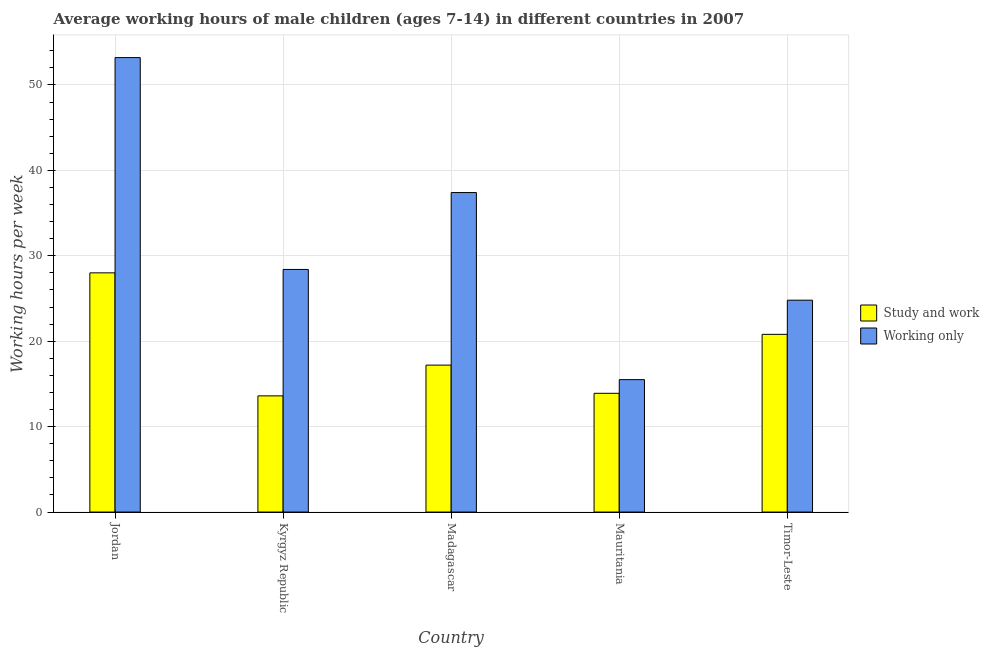How many different coloured bars are there?
Provide a succinct answer. 2. How many groups of bars are there?
Keep it short and to the point. 5. How many bars are there on the 5th tick from the right?
Your response must be concise. 2. What is the label of the 1st group of bars from the left?
Offer a very short reply. Jordan. Across all countries, what is the maximum average working hour of children involved in only work?
Your answer should be very brief. 53.2. Across all countries, what is the minimum average working hour of children involved in only work?
Keep it short and to the point. 15.5. In which country was the average working hour of children involved in only work maximum?
Your answer should be compact. Jordan. In which country was the average working hour of children involved in study and work minimum?
Ensure brevity in your answer.  Kyrgyz Republic. What is the total average working hour of children involved in study and work in the graph?
Your answer should be very brief. 93.5. What is the difference between the average working hour of children involved in only work in Madagascar and that in Mauritania?
Provide a short and direct response. 21.9. What is the difference between the average working hour of children involved in only work in Madagascar and the average working hour of children involved in study and work in Jordan?
Provide a short and direct response. 9.4. What is the average average working hour of children involved in only work per country?
Your answer should be very brief. 31.86. What is the difference between the average working hour of children involved in only work and average working hour of children involved in study and work in Madagascar?
Offer a terse response. 20.2. What is the ratio of the average working hour of children involved in study and work in Jordan to that in Timor-Leste?
Provide a short and direct response. 1.35. What is the difference between the highest and the second highest average working hour of children involved in study and work?
Offer a terse response. 7.2. What is the difference between the highest and the lowest average working hour of children involved in only work?
Your response must be concise. 37.7. Is the sum of the average working hour of children involved in only work in Kyrgyz Republic and Mauritania greater than the maximum average working hour of children involved in study and work across all countries?
Ensure brevity in your answer.  Yes. What does the 1st bar from the left in Madagascar represents?
Offer a very short reply. Study and work. What does the 2nd bar from the right in Kyrgyz Republic represents?
Offer a terse response. Study and work. How many bars are there?
Make the answer very short. 10. Are all the bars in the graph horizontal?
Your answer should be very brief. No. How many countries are there in the graph?
Provide a short and direct response. 5. What is the difference between two consecutive major ticks on the Y-axis?
Your answer should be very brief. 10. Does the graph contain any zero values?
Offer a very short reply. No. Where does the legend appear in the graph?
Give a very brief answer. Center right. How many legend labels are there?
Your answer should be compact. 2. What is the title of the graph?
Your response must be concise. Average working hours of male children (ages 7-14) in different countries in 2007. What is the label or title of the Y-axis?
Give a very brief answer. Working hours per week. What is the Working hours per week of Working only in Jordan?
Offer a very short reply. 53.2. What is the Working hours per week of Working only in Kyrgyz Republic?
Make the answer very short. 28.4. What is the Working hours per week in Working only in Madagascar?
Your answer should be compact. 37.4. What is the Working hours per week of Working only in Mauritania?
Provide a short and direct response. 15.5. What is the Working hours per week in Study and work in Timor-Leste?
Your response must be concise. 20.8. What is the Working hours per week of Working only in Timor-Leste?
Keep it short and to the point. 24.8. Across all countries, what is the maximum Working hours per week in Study and work?
Keep it short and to the point. 28. Across all countries, what is the maximum Working hours per week of Working only?
Give a very brief answer. 53.2. Across all countries, what is the minimum Working hours per week in Working only?
Give a very brief answer. 15.5. What is the total Working hours per week of Study and work in the graph?
Your answer should be very brief. 93.5. What is the total Working hours per week in Working only in the graph?
Provide a short and direct response. 159.3. What is the difference between the Working hours per week in Working only in Jordan and that in Kyrgyz Republic?
Ensure brevity in your answer.  24.8. What is the difference between the Working hours per week of Study and work in Jordan and that in Madagascar?
Provide a short and direct response. 10.8. What is the difference between the Working hours per week of Working only in Jordan and that in Madagascar?
Make the answer very short. 15.8. What is the difference between the Working hours per week in Study and work in Jordan and that in Mauritania?
Give a very brief answer. 14.1. What is the difference between the Working hours per week of Working only in Jordan and that in Mauritania?
Offer a terse response. 37.7. What is the difference between the Working hours per week in Working only in Jordan and that in Timor-Leste?
Your response must be concise. 28.4. What is the difference between the Working hours per week of Study and work in Kyrgyz Republic and that in Madagascar?
Provide a succinct answer. -3.6. What is the difference between the Working hours per week of Study and work in Kyrgyz Republic and that in Mauritania?
Your response must be concise. -0.3. What is the difference between the Working hours per week in Working only in Kyrgyz Republic and that in Mauritania?
Give a very brief answer. 12.9. What is the difference between the Working hours per week in Study and work in Kyrgyz Republic and that in Timor-Leste?
Provide a short and direct response. -7.2. What is the difference between the Working hours per week of Study and work in Madagascar and that in Mauritania?
Provide a short and direct response. 3.3. What is the difference between the Working hours per week of Working only in Madagascar and that in Mauritania?
Provide a succinct answer. 21.9. What is the difference between the Working hours per week in Working only in Madagascar and that in Timor-Leste?
Provide a succinct answer. 12.6. What is the difference between the Working hours per week of Study and work in Mauritania and that in Timor-Leste?
Offer a terse response. -6.9. What is the difference between the Working hours per week in Working only in Mauritania and that in Timor-Leste?
Offer a terse response. -9.3. What is the difference between the Working hours per week of Study and work in Jordan and the Working hours per week of Working only in Madagascar?
Your response must be concise. -9.4. What is the difference between the Working hours per week in Study and work in Jordan and the Working hours per week in Working only in Timor-Leste?
Provide a succinct answer. 3.2. What is the difference between the Working hours per week of Study and work in Kyrgyz Republic and the Working hours per week of Working only in Madagascar?
Offer a very short reply. -23.8. What is the difference between the Working hours per week in Study and work in Kyrgyz Republic and the Working hours per week in Working only in Timor-Leste?
Your answer should be compact. -11.2. What is the difference between the Working hours per week in Study and work in Madagascar and the Working hours per week in Working only in Mauritania?
Your answer should be very brief. 1.7. What is the difference between the Working hours per week in Study and work in Madagascar and the Working hours per week in Working only in Timor-Leste?
Make the answer very short. -7.6. What is the average Working hours per week in Study and work per country?
Ensure brevity in your answer.  18.7. What is the average Working hours per week of Working only per country?
Offer a terse response. 31.86. What is the difference between the Working hours per week in Study and work and Working hours per week in Working only in Jordan?
Offer a very short reply. -25.2. What is the difference between the Working hours per week of Study and work and Working hours per week of Working only in Kyrgyz Republic?
Provide a succinct answer. -14.8. What is the difference between the Working hours per week of Study and work and Working hours per week of Working only in Madagascar?
Offer a very short reply. -20.2. What is the difference between the Working hours per week of Study and work and Working hours per week of Working only in Mauritania?
Offer a very short reply. -1.6. What is the difference between the Working hours per week of Study and work and Working hours per week of Working only in Timor-Leste?
Give a very brief answer. -4. What is the ratio of the Working hours per week in Study and work in Jordan to that in Kyrgyz Republic?
Make the answer very short. 2.06. What is the ratio of the Working hours per week of Working only in Jordan to that in Kyrgyz Republic?
Keep it short and to the point. 1.87. What is the ratio of the Working hours per week of Study and work in Jordan to that in Madagascar?
Provide a succinct answer. 1.63. What is the ratio of the Working hours per week of Working only in Jordan to that in Madagascar?
Your response must be concise. 1.42. What is the ratio of the Working hours per week in Study and work in Jordan to that in Mauritania?
Your response must be concise. 2.01. What is the ratio of the Working hours per week of Working only in Jordan to that in Mauritania?
Your answer should be very brief. 3.43. What is the ratio of the Working hours per week in Study and work in Jordan to that in Timor-Leste?
Your response must be concise. 1.35. What is the ratio of the Working hours per week in Working only in Jordan to that in Timor-Leste?
Your answer should be compact. 2.15. What is the ratio of the Working hours per week of Study and work in Kyrgyz Republic to that in Madagascar?
Provide a short and direct response. 0.79. What is the ratio of the Working hours per week in Working only in Kyrgyz Republic to that in Madagascar?
Give a very brief answer. 0.76. What is the ratio of the Working hours per week of Study and work in Kyrgyz Republic to that in Mauritania?
Ensure brevity in your answer.  0.98. What is the ratio of the Working hours per week of Working only in Kyrgyz Republic to that in Mauritania?
Ensure brevity in your answer.  1.83. What is the ratio of the Working hours per week of Study and work in Kyrgyz Republic to that in Timor-Leste?
Ensure brevity in your answer.  0.65. What is the ratio of the Working hours per week in Working only in Kyrgyz Republic to that in Timor-Leste?
Give a very brief answer. 1.15. What is the ratio of the Working hours per week in Study and work in Madagascar to that in Mauritania?
Ensure brevity in your answer.  1.24. What is the ratio of the Working hours per week in Working only in Madagascar to that in Mauritania?
Your answer should be compact. 2.41. What is the ratio of the Working hours per week of Study and work in Madagascar to that in Timor-Leste?
Make the answer very short. 0.83. What is the ratio of the Working hours per week of Working only in Madagascar to that in Timor-Leste?
Offer a very short reply. 1.51. What is the ratio of the Working hours per week in Study and work in Mauritania to that in Timor-Leste?
Offer a very short reply. 0.67. What is the difference between the highest and the second highest Working hours per week in Study and work?
Make the answer very short. 7.2. What is the difference between the highest and the lowest Working hours per week in Working only?
Keep it short and to the point. 37.7. 